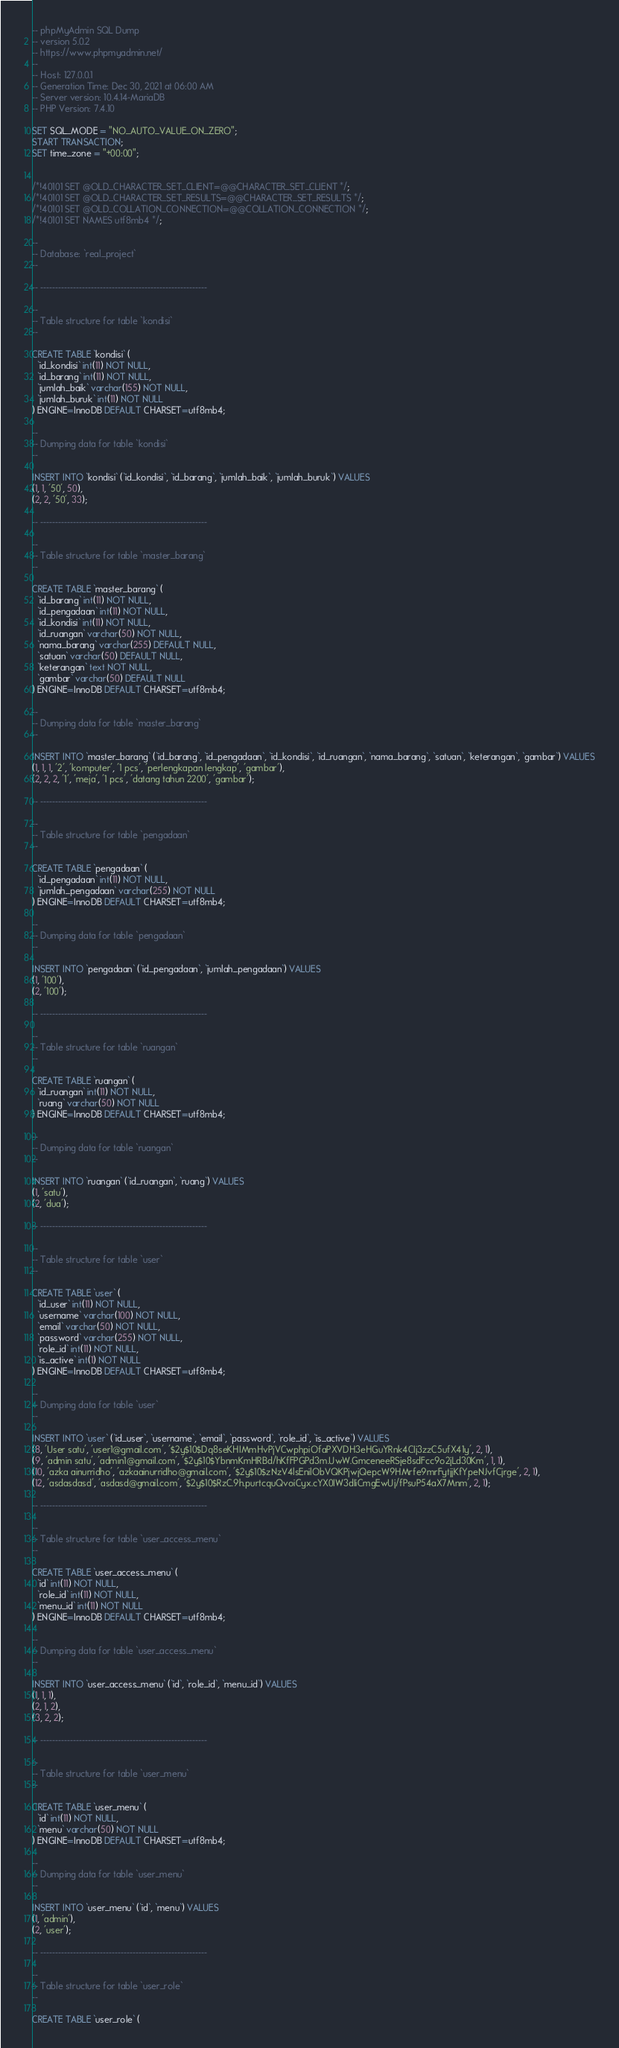Convert code to text. <code><loc_0><loc_0><loc_500><loc_500><_SQL_>-- phpMyAdmin SQL Dump
-- version 5.0.2
-- https://www.phpmyadmin.net/
--
-- Host: 127.0.0.1
-- Generation Time: Dec 30, 2021 at 06:00 AM
-- Server version: 10.4.14-MariaDB
-- PHP Version: 7.4.10

SET SQL_MODE = "NO_AUTO_VALUE_ON_ZERO";
START TRANSACTION;
SET time_zone = "+00:00";


/*!40101 SET @OLD_CHARACTER_SET_CLIENT=@@CHARACTER_SET_CLIENT */;
/*!40101 SET @OLD_CHARACTER_SET_RESULTS=@@CHARACTER_SET_RESULTS */;
/*!40101 SET @OLD_COLLATION_CONNECTION=@@COLLATION_CONNECTION */;
/*!40101 SET NAMES utf8mb4 */;

--
-- Database: `real_project`
--

-- --------------------------------------------------------

--
-- Table structure for table `kondisi`
--

CREATE TABLE `kondisi` (
  `id_kondisi` int(11) NOT NULL,
  `id_barang` int(11) NOT NULL,
  `jumlah_baik` varchar(155) NOT NULL,
  `jumlah_buruk` int(11) NOT NULL
) ENGINE=InnoDB DEFAULT CHARSET=utf8mb4;

--
-- Dumping data for table `kondisi`
--

INSERT INTO `kondisi` (`id_kondisi`, `id_barang`, `jumlah_baik`, `jumlah_buruk`) VALUES
(1, 1, '50', 50),
(2, 2, '50', 33);

-- --------------------------------------------------------

--
-- Table structure for table `master_barang`
--

CREATE TABLE `master_barang` (
  `id_barang` int(11) NOT NULL,
  `id_pengadaan` int(11) NOT NULL,
  `id_kondisi` int(11) NOT NULL,
  `id_ruangan` varchar(50) NOT NULL,
  `nama_barang` varchar(255) DEFAULT NULL,
  `satuan` varchar(50) DEFAULT NULL,
  `keterangan` text NOT NULL,
  `gambar` varchar(50) DEFAULT NULL
) ENGINE=InnoDB DEFAULT CHARSET=utf8mb4;

--
-- Dumping data for table `master_barang`
--

INSERT INTO `master_barang` (`id_barang`, `id_pengadaan`, `id_kondisi`, `id_ruangan`, `nama_barang`, `satuan`, `keterangan`, `gambar`) VALUES
(1, 1, 1, '2', 'komputer', '1 pcs', 'perlengkapan lengkap', 'gambar'),
(2, 2, 2, '1', 'meja', '1 pcs', 'datang tahun 2200', 'gambar');

-- --------------------------------------------------------

--
-- Table structure for table `pengadaan`
--

CREATE TABLE `pengadaan` (
  `id_pengadaan` int(11) NOT NULL,
  `jumlah_pengadaan` varchar(255) NOT NULL
) ENGINE=InnoDB DEFAULT CHARSET=utf8mb4;

--
-- Dumping data for table `pengadaan`
--

INSERT INTO `pengadaan` (`id_pengadaan`, `jumlah_pengadaan`) VALUES
(1, '100'),
(2, '100');

-- --------------------------------------------------------

--
-- Table structure for table `ruangan`
--

CREATE TABLE `ruangan` (
  `id_ruangan` int(11) NOT NULL,
  `ruang` varchar(50) NOT NULL
) ENGINE=InnoDB DEFAULT CHARSET=utf8mb4;

--
-- Dumping data for table `ruangan`
--

INSERT INTO `ruangan` (`id_ruangan`, `ruang`) VALUES
(1, 'satu'),
(2, 'dua');

-- --------------------------------------------------------

--
-- Table structure for table `user`
--

CREATE TABLE `user` (
  `id_user` int(11) NOT NULL,
  `username` varchar(100) NOT NULL,
  `email` varchar(50) NOT NULL,
  `password` varchar(255) NOT NULL,
  `role_id` int(11) NOT NULL,
  `is_active` int(1) NOT NULL
) ENGINE=InnoDB DEFAULT CHARSET=utf8mb4;

--
-- Dumping data for table `user`
--

INSERT INTO `user` (`id_user`, `username`, `email`, `password`, `role_id`, `is_active`) VALUES
(8, 'User satu', 'user1@gmail.com', '$2y$10$Dq8seKHIMmHvPjVCwphpiOfaPXVDH3eHGuYRnk4CIj3zzC5ufX41y', 2, 1),
(9, 'admin satu', 'admin1@gmail.com', '$2y$10$YbnmKmHRBd/hKfFPGPd3m.UwW.GmceneeRSje8sdFcc9o2jLd30Km', 1, 1),
(10, 'azka ainurridho', 'azkaainurridho@gmail.com', '$2y$10$zNzV4lsEnilObVQKPjwjQepcW9HMrfe9mrFytjjKfYpeNJvfCjrge', 2, 1),
(12, 'asdasdasd', 'asdasd@gmail.com', '$2y$10$RzC.9h.purtcquQvoiCyx.cYX0IW3dIiCmgEwUj/fPsuP54aX7Mnm', 2, 1);

-- --------------------------------------------------------

--
-- Table structure for table `user_access_menu`
--

CREATE TABLE `user_access_menu` (
  `id` int(11) NOT NULL,
  `role_id` int(11) NOT NULL,
  `menu_id` int(11) NOT NULL
) ENGINE=InnoDB DEFAULT CHARSET=utf8mb4;

--
-- Dumping data for table `user_access_menu`
--

INSERT INTO `user_access_menu` (`id`, `role_id`, `menu_id`) VALUES
(1, 1, 1),
(2, 1, 2),
(3, 2, 2);

-- --------------------------------------------------------

--
-- Table structure for table `user_menu`
--

CREATE TABLE `user_menu` (
  `id` int(11) NOT NULL,
  `menu` varchar(50) NOT NULL
) ENGINE=InnoDB DEFAULT CHARSET=utf8mb4;

--
-- Dumping data for table `user_menu`
--

INSERT INTO `user_menu` (`id`, `menu`) VALUES
(1, 'admin'),
(2, 'user');

-- --------------------------------------------------------

--
-- Table structure for table `user_role`
--

CREATE TABLE `user_role` (</code> 